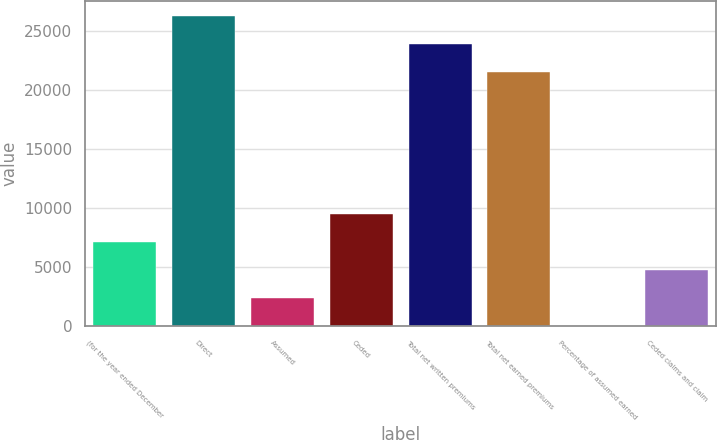<chart> <loc_0><loc_0><loc_500><loc_500><bar_chart><fcel>(for the year ended December<fcel>Direct<fcel>Assumed<fcel>Ceded<fcel>Total net written premiums<fcel>Total net earned premiums<fcel>Percentage of assumed earned<fcel>Ceded claims and claim<nl><fcel>7147.76<fcel>26234.6<fcel>2383.12<fcel>9530.08<fcel>23852.3<fcel>21470<fcel>0.8<fcel>4765.44<nl></chart> 